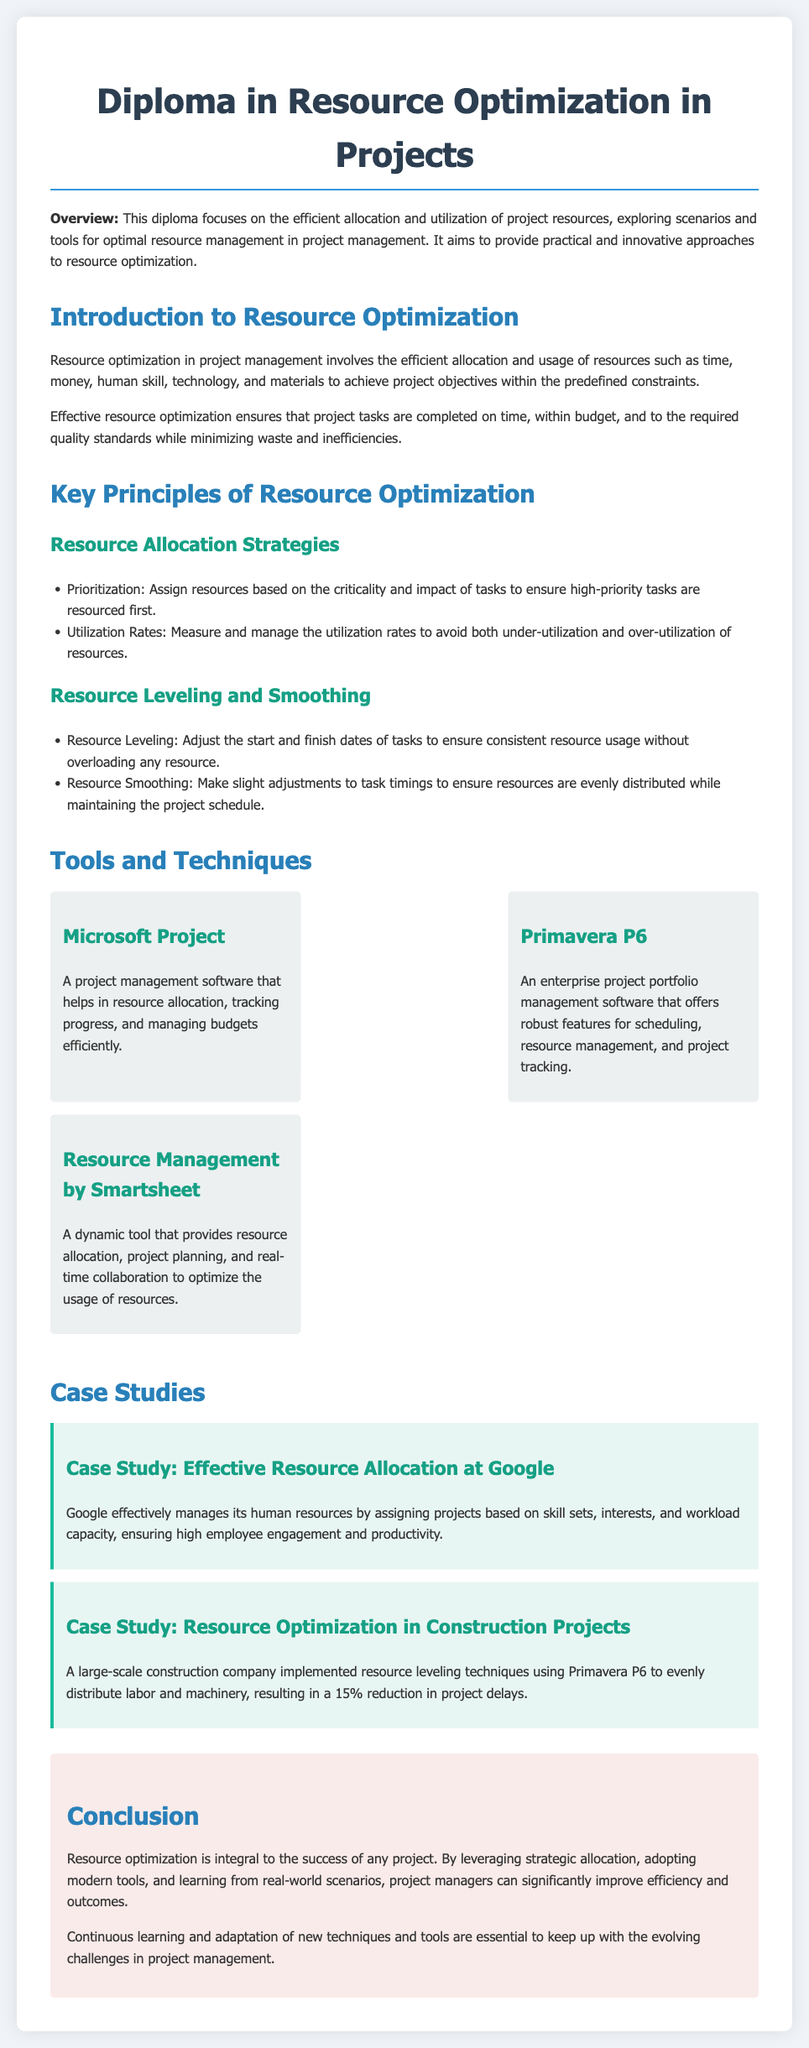What is the title of the diploma? The title of the diploma is highlighted at the top of the document.
Answer: Diploma in Resource Optimization in Projects What are the key principles of resource optimization mentioned? The document lists key principles under a heading.
Answer: Resource Allocation Strategies, Resource Leveling and Smoothing Which tool is used for project management and helps in budget management? The document specifies tools and their functions.
Answer: Microsoft Project What percentage reduction in project delays was achieved by the construction company? This information is found in a specific case study.
Answer: 15% What does effective resource optimization aim to ensure? The document outlines objectives of resource optimization.
Answer: Completion of project tasks on time, within budget, and to quality standards What type of management software is Primavera P6 categorized as? The document provides a classification for Primavera P6.
Answer: Enterprise project portfolio management software What is one strategy for resource allocation mentioned in the document? The document lists strategies under the key principles section.
Answer: Prioritization What is the background color of the conclusion section? This can be inferred from the document styling.
Answer: Light pink (f9ebea) 